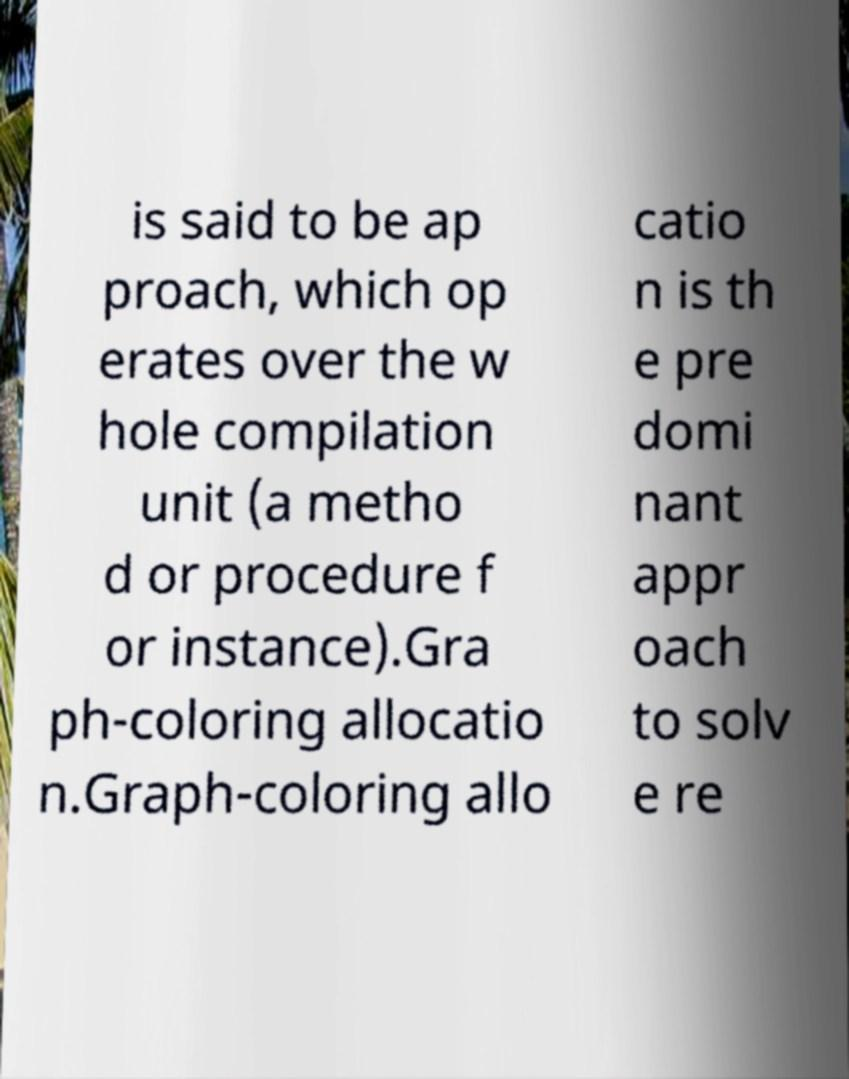For documentation purposes, I need the text within this image transcribed. Could you provide that? is said to be ap proach, which op erates over the w hole compilation unit (a metho d or procedure f or instance).Gra ph-coloring allocatio n.Graph-coloring allo catio n is th e pre domi nant appr oach to solv e re 